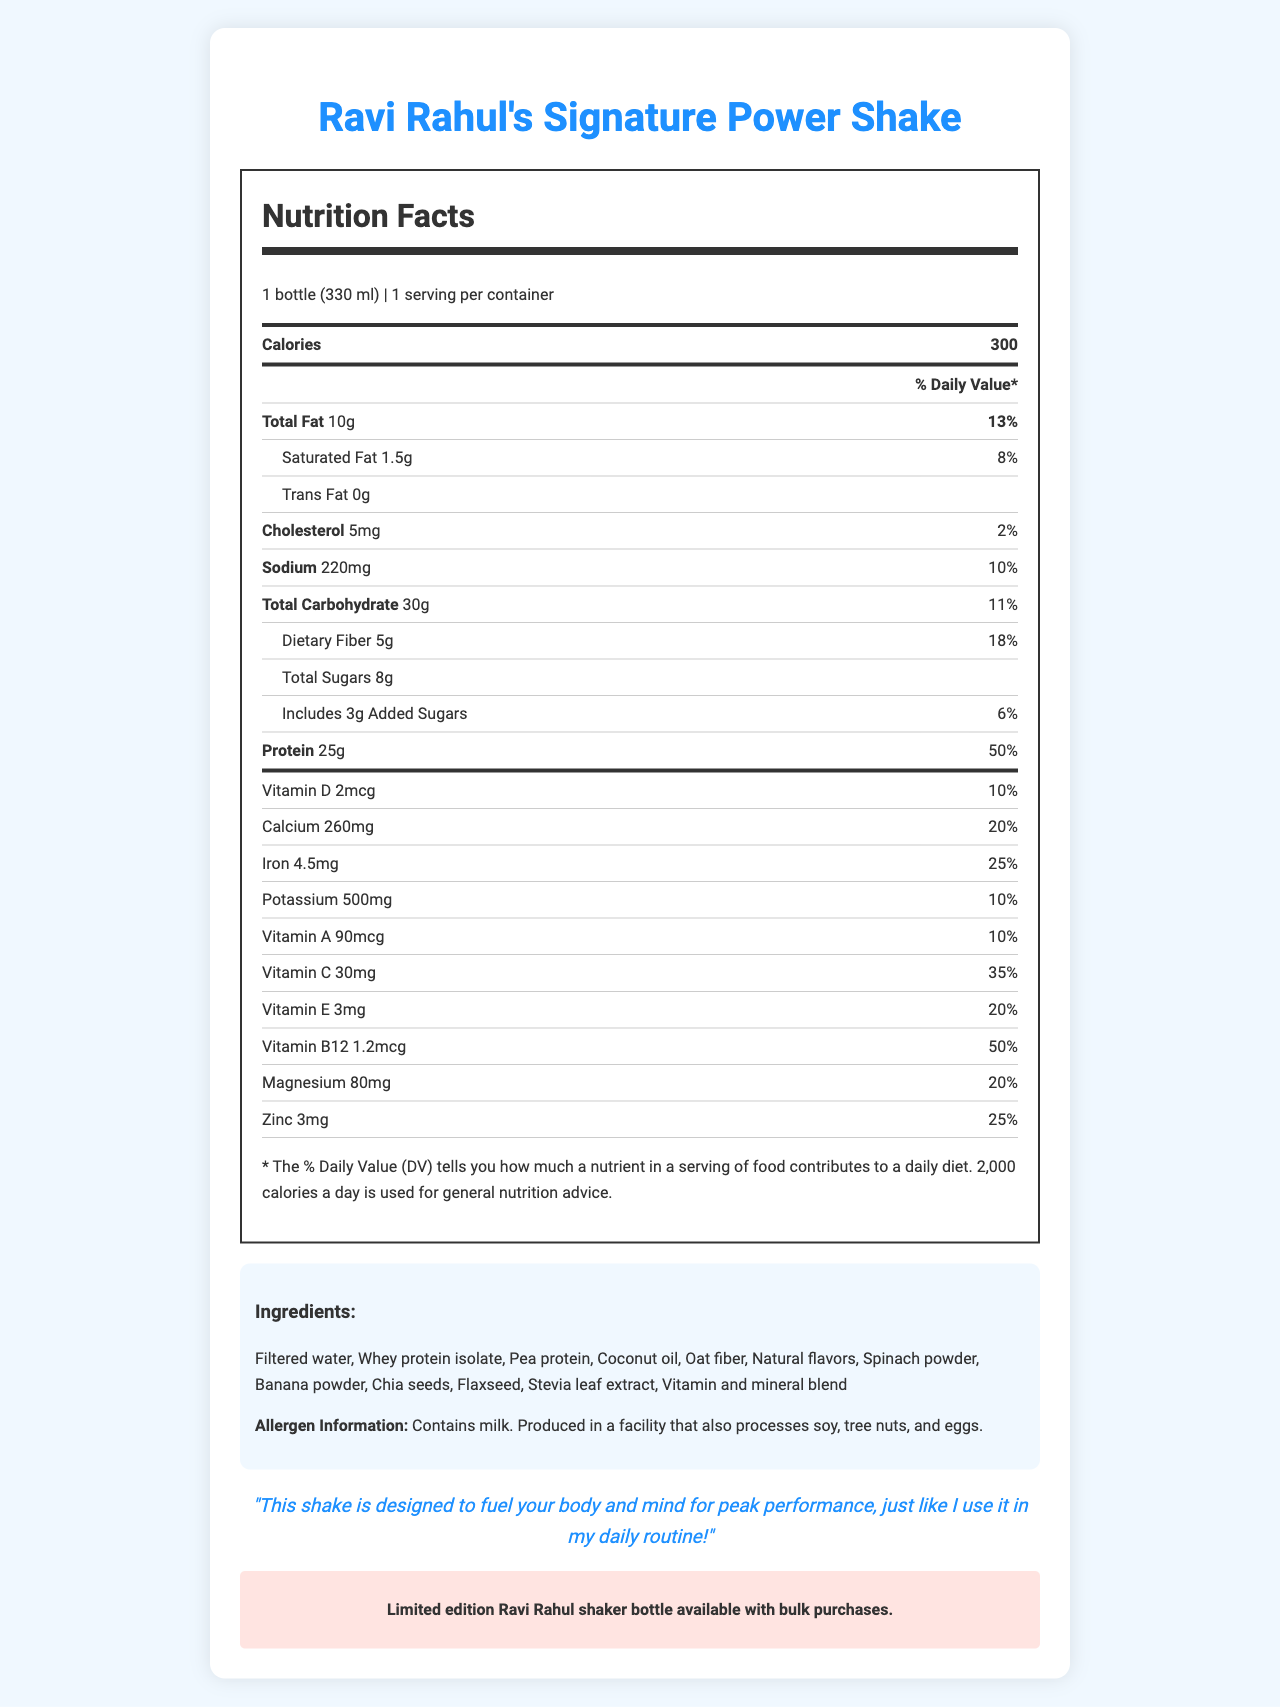how many servings are in the bottle? Each bottle is listed as 1 serving per container.
Answer: 1 how many grams of protein are in one serving of the shake? The document specifies that each serving of the shake contains 25 grams of protein.
Answer: 25g what percentage of the daily value for dietary fiber does one serving of the shake provide? The Nutrition Facts label shows that one serving provides 18% of the daily value for dietary fiber.
Answer: 18% which ingredient comes first in the list of ingredients? The first ingredient listed is filtered water.
Answer: Filtered water does the shake contain any trans fat? The document specifically states that the trans fat content is 0g.
Answer: No which vitamin has the highest daily value percentage in the shake? A. Vitamin D B. Vitamin C C. Vitamin B12 D. Vitamin A Vitamin B12 has a daily value of 50%, which is the highest among the listed vitamins.
Answer: C. Vitamin B12 how many total calories are in one serving of the shake? A. 200 B. 250 C. 300 D. 350 One serving contains 300 calories, as specified in the Nutrition Facts label.
Answer: C. 300 is the shake suitable for someone with a nut allergy? Although the shake itself does not contain nuts, it is produced in a facility that also processes soy, tree nuts, and eggs, which may pose a risk for cross-contamination.
Answer: No/Not necessarily what is the primary purpose of the document? The document aims to inform consumers about the nutritional content, ingredients, and allergen information of the shake.
Answer: To provide detailed nutritional information about Ravi Rahul's Signature Power Shake who is Ravi Rahul? The document does not provide any detailed information about who Ravi Rahul is, beyond suggesting he uses the shake for peak performance.
Answer: Cannot be determined 